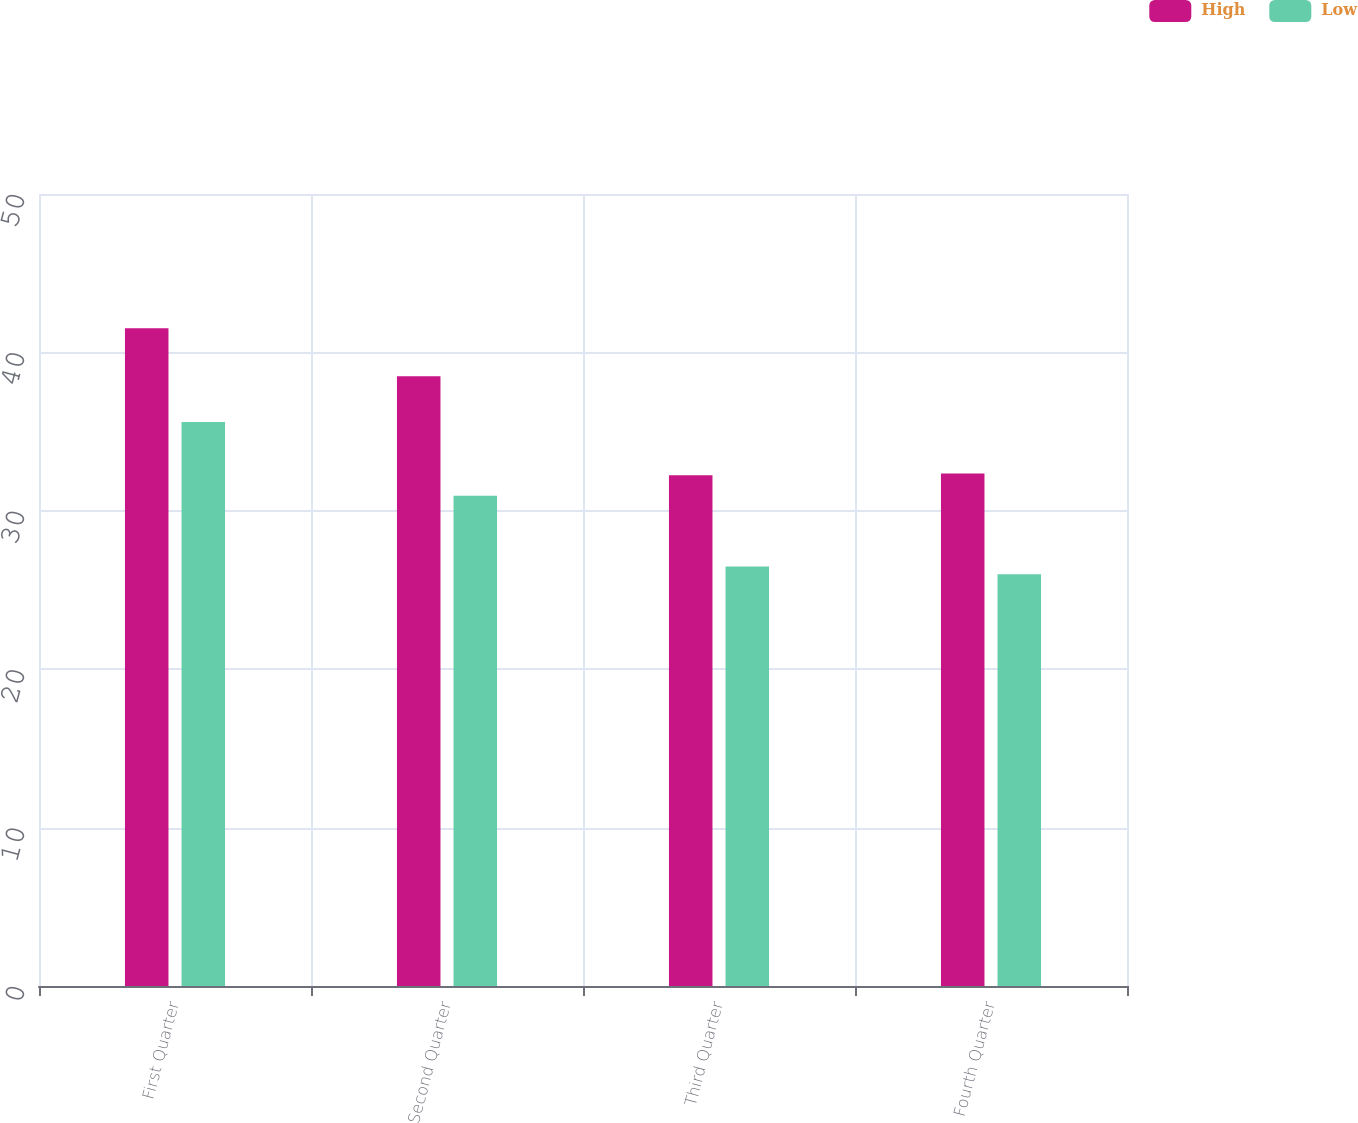Convert chart. <chart><loc_0><loc_0><loc_500><loc_500><stacked_bar_chart><ecel><fcel>First Quarter<fcel>Second Quarter<fcel>Third Quarter<fcel>Fourth Quarter<nl><fcel>High<fcel>41.53<fcel>38.49<fcel>32.25<fcel>32.35<nl><fcel>Low<fcel>35.6<fcel>30.95<fcel>26.49<fcel>25.99<nl></chart> 